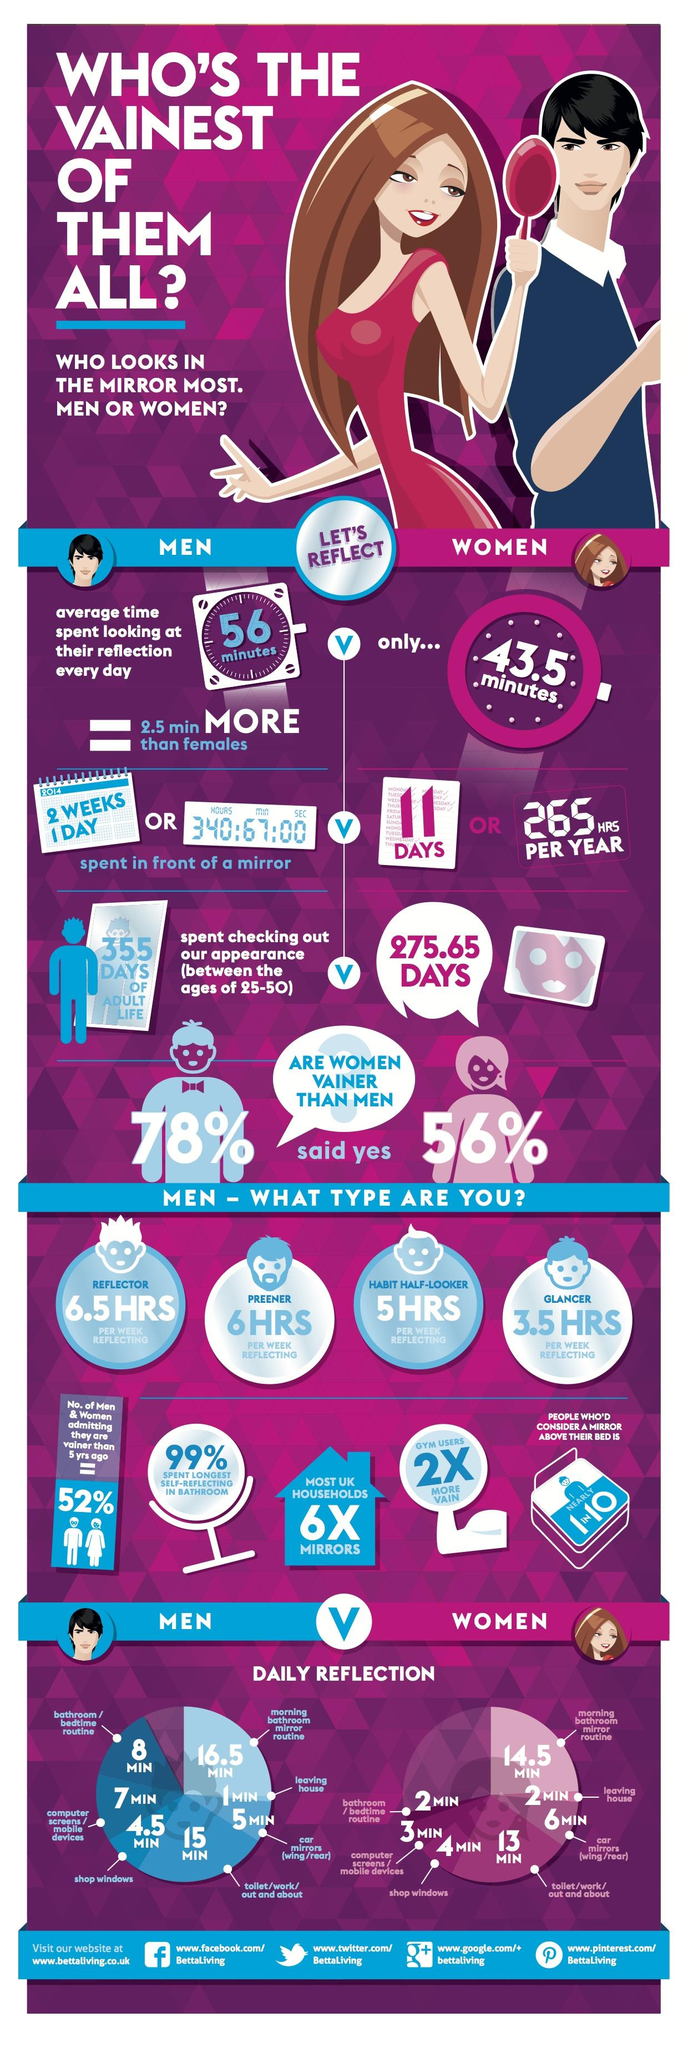Identify some key points in this picture. I spend only 15 days in front of a mirror. I spend the least amount of time per week in front of the mirror, reflector, preener, habit half-looker, or glancer. A woman spends approximately 275.65 days gazing at her reflection in the mirror during the course of her adult life. A woman spent 4 minutes looking at her reflection while standing in front of shop windows. The time spent by a man looking at his reflection before leaving home is 1 minute, 2 minutes, or 5 minutes. 